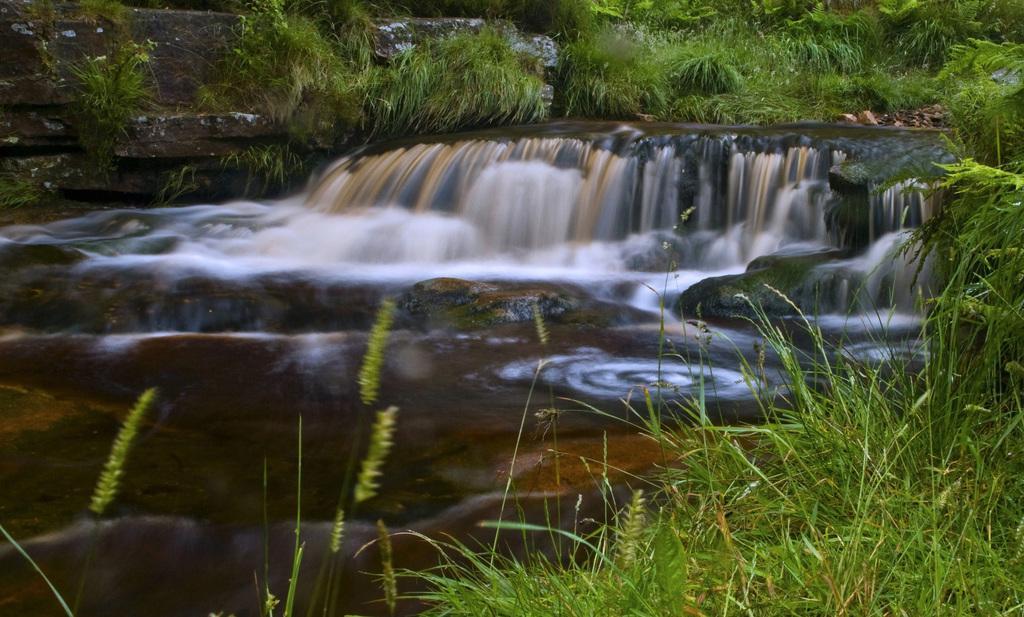Can you describe this image briefly? In this image in the middle, there are water falls. At the bottom there are plants, grass, stones and water. At the top there are plants, grass and stones. 